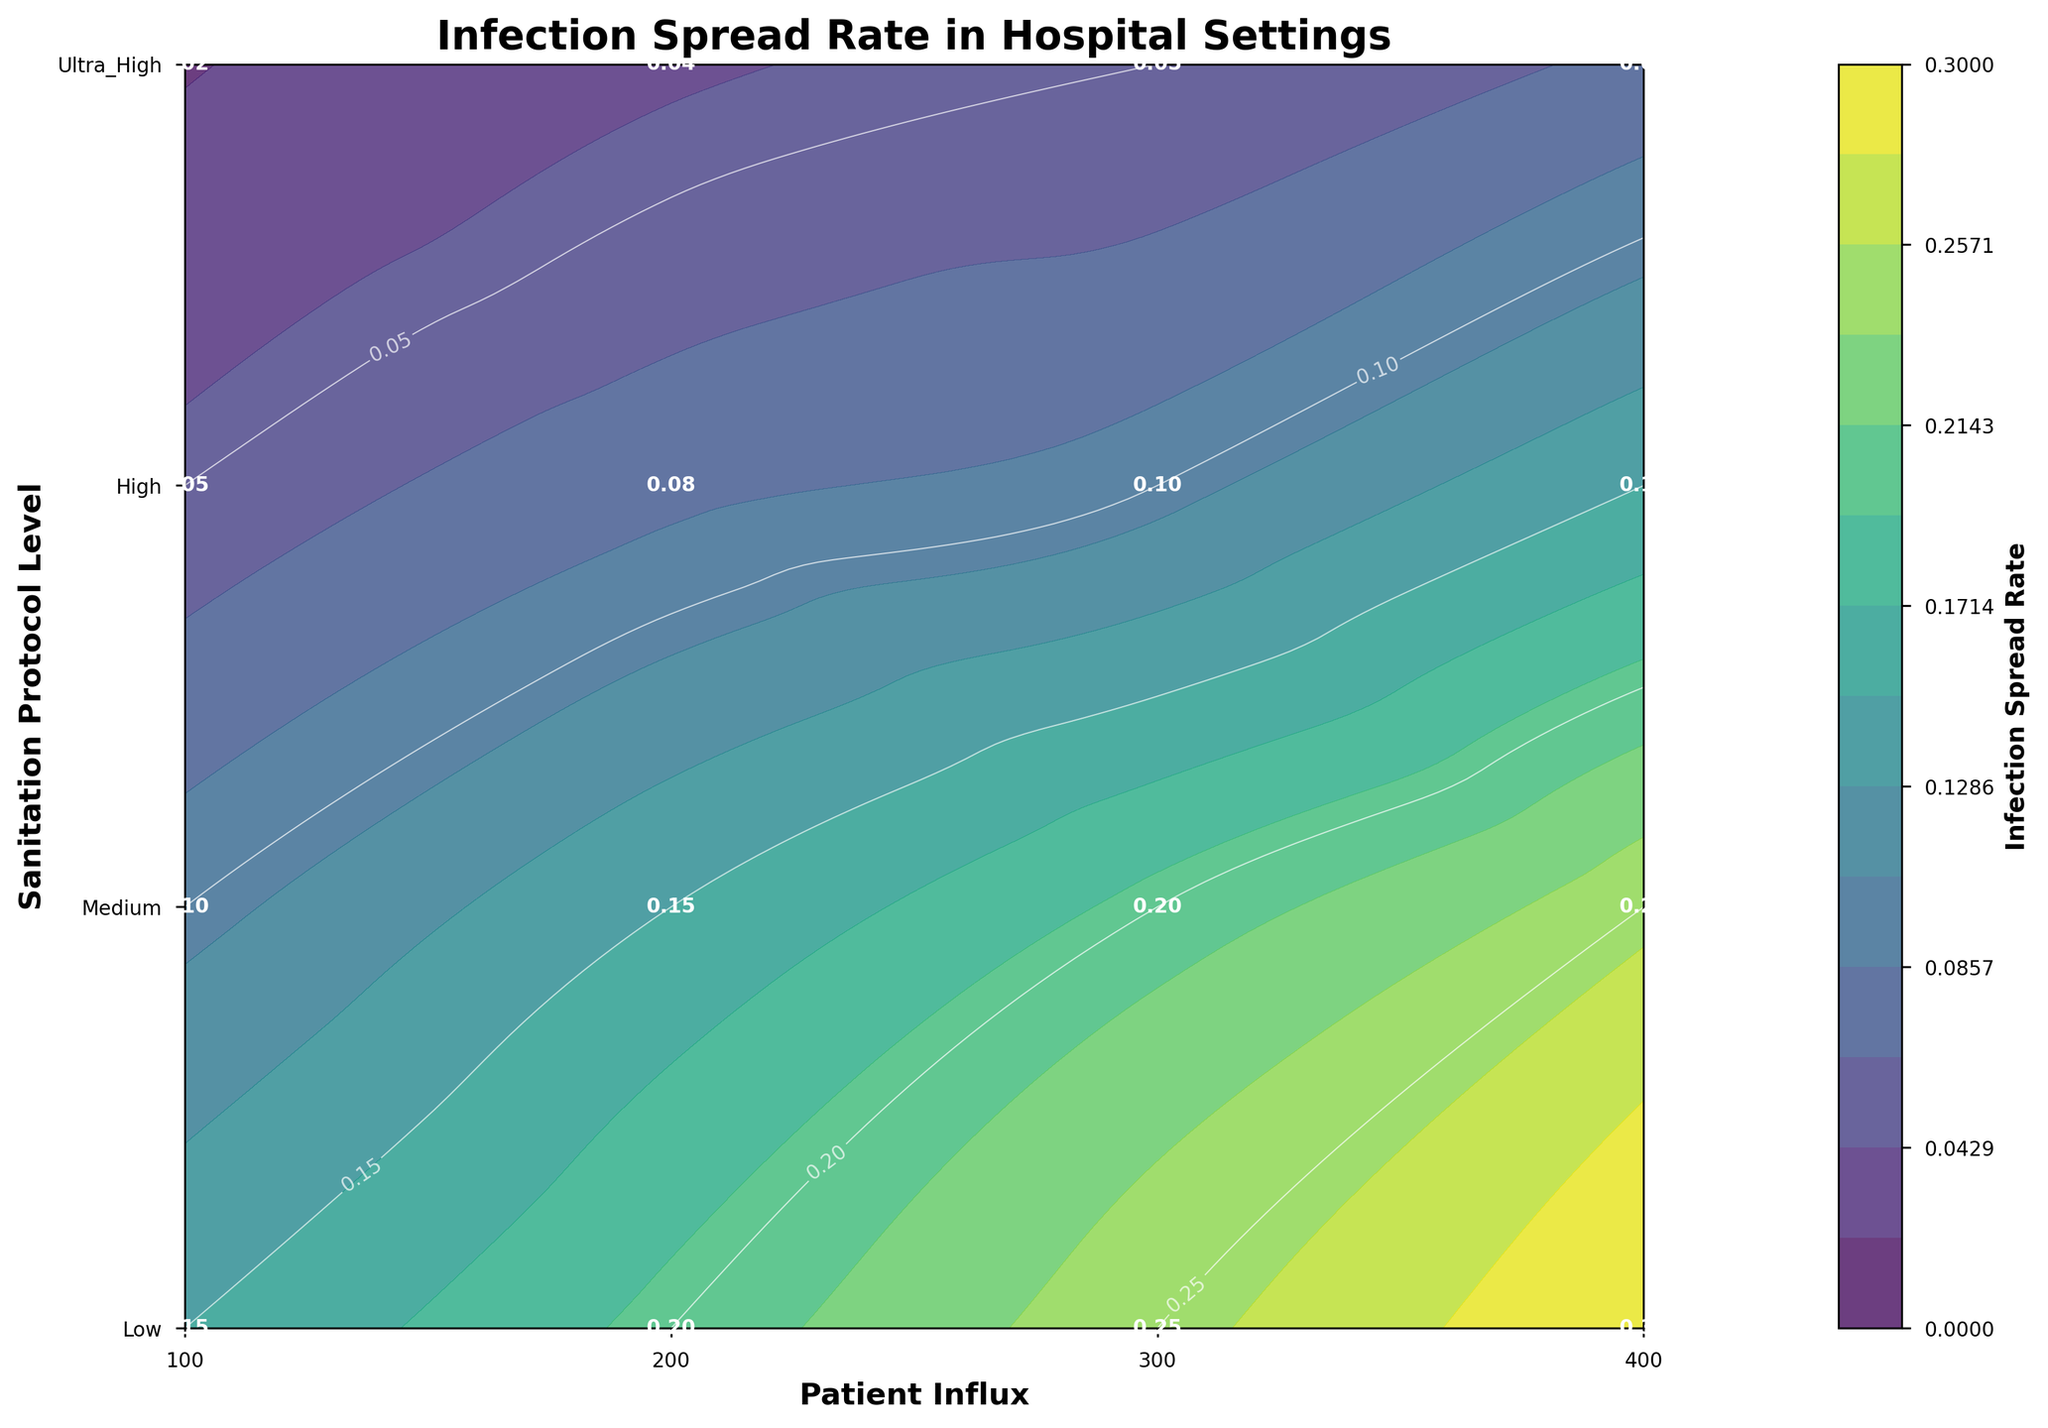What is the highest infection spread rate at the "Low" sanitation protocol level? First, locate the "Low" sanitation protocol level on the y-axis. Then find the highest infection spread rate value within this row. The highest value for "Low" sanitation protocol is 0.30.
Answer: 0.30 What is the general trend of the infection spread rate when the sanitation protocol level increases from "Low" to "Ultra High"? Observe the values across the rows from "Low" to "Ultra High". Notice that the infection spread rate values generally decrease as the sanitation protocol level increases.
Answer: Decreasing trend At which patient influx does the infection spread rate become less than 0.10 for the first time and at what sanitation protocol level? Look along the x-axis (patient influx) for values less than 0.10. Notice it's first less than 0.10 at "Medium" sanitation protocol level for a patient influx of 100.
Answer: 100, Medium For a "High" sanitation protocol level, what is the difference in infection spread rates between a patient influx of 100 and 400? Find the infection spread rate at "High" sanitation protocol level for 100 and 400 patient influx, which are 0.05 and 0.15 respectively. Subtract the smaller value from the larger one (0.15 - 0.05 = 0.10).
Answer: 0.10 Which sanitation protocol level and patient influx combination results in the lowest infection spread rate? Scan all the values to find the lowest infection spread rate, which is 0.02 at "Ultra_High" sanitation protocol level with a patient influx of 100.
Answer: Ultra_High, 100 Between "Medium" and "High" sanitation protocol levels, for which patient influx interval does the infection spread rate change the most? Compare values row-wise between "Medium" and "High" levels across different patient influx intervals. The change is maximum between "Medium" (0.25) and "High" (0.15) sanitation protocol levels for 400 patient influx (0.25 - 0.15 = 0.10).
Answer: 400 What is the infection spread rate for "Ultra_High" sanitation protocol level with a patient influx of 300? Find the row for "Ultra_High" sanitation protocol level and then locate the column for patient influx of 300. The corresponding infection spread rate is 0.05.
Answer: 0.05 